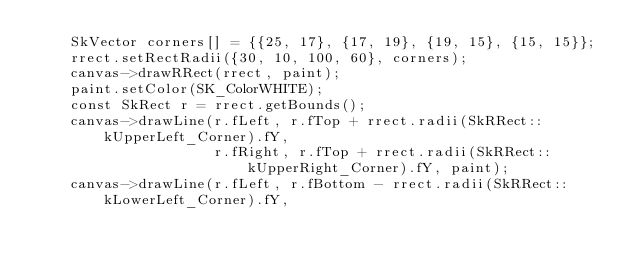Convert code to text. <code><loc_0><loc_0><loc_500><loc_500><_C++_>    SkVector corners[] = {{25, 17}, {17, 19}, {19, 15}, {15, 15}};
    rrect.setRectRadii({30, 10, 100, 60}, corners);
    canvas->drawRRect(rrect, paint);
    paint.setColor(SK_ColorWHITE);
    const SkRect r = rrect.getBounds();
    canvas->drawLine(r.fLeft, r.fTop + rrect.radii(SkRRect::kUpperLeft_Corner).fY,
                     r.fRight, r.fTop + rrect.radii(SkRRect::kUpperRight_Corner).fY, paint);
    canvas->drawLine(r.fLeft, r.fBottom - rrect.radii(SkRRect::kLowerLeft_Corner).fY,</code> 